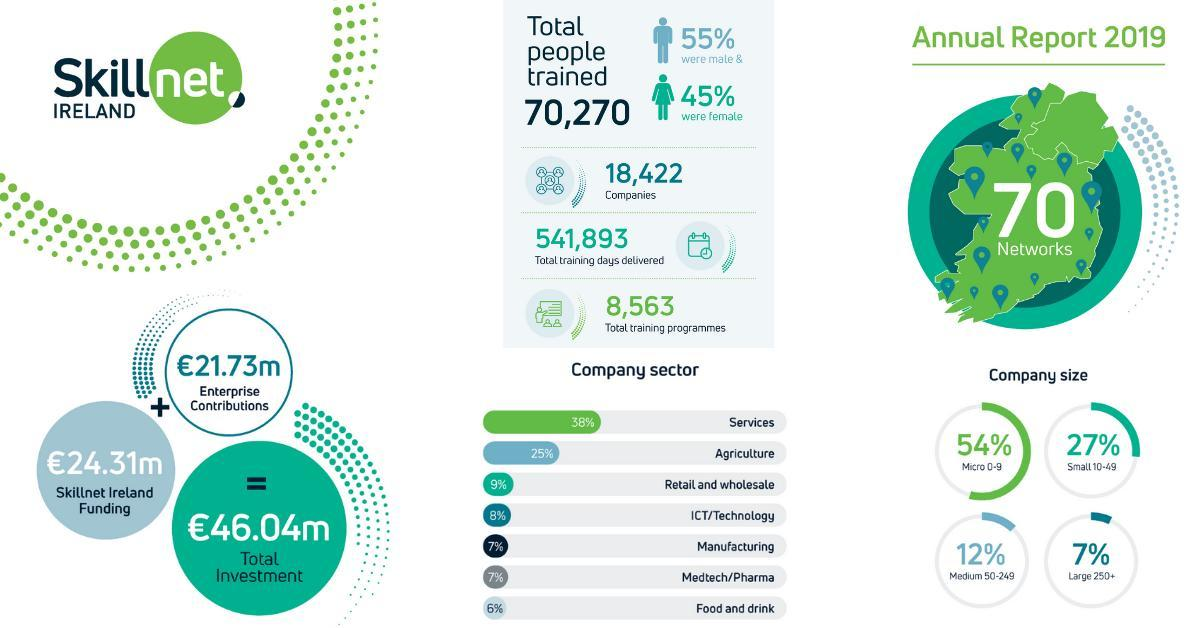What percentage of total trained people in Ireland were female as of 2019 annual report?
Answer the question with a short phrase. 45% How much is the fund raised by Skillnet Ireland as of 2019 annual report? €24.31m What percentage of total trained people in Ireland were male as of 2019 annual report? 55% 